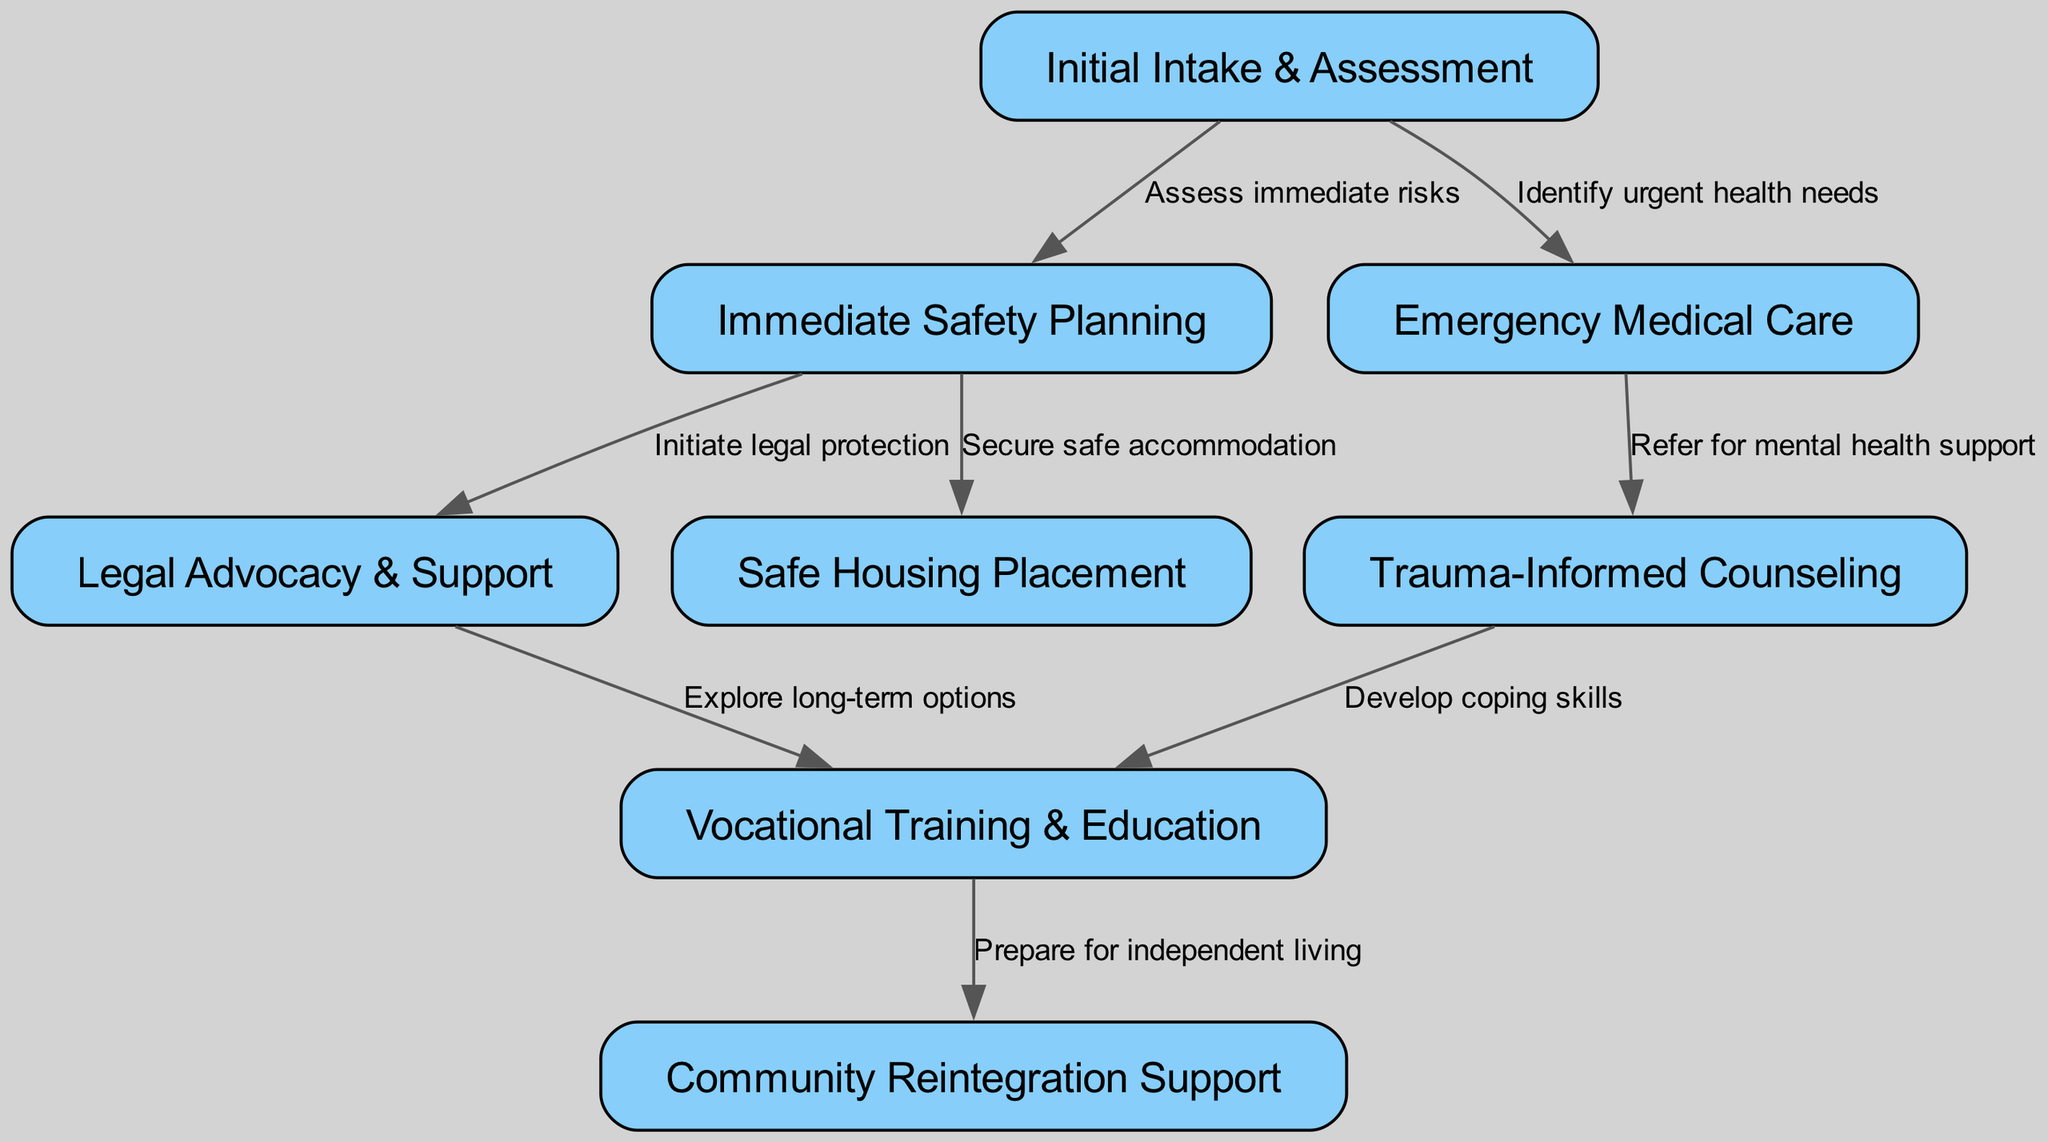What is the first step in the pathway? The diagram indicates that the first step is "Initial Intake & Assessment," which is the starting point of the clinical pathway for support services.
Answer: Initial Intake & Assessment How many nodes are present in the diagram? The diagram contains 8 nodes, each representing a different stage or aspect of the support process for trafficking survivors.
Answer: 8 What service follows “Emergency Medical Care”? After "Emergency Medical Care," the next step indicated in the diagram is "Trauma-Informed Counseling," showing a direct connection from medical care to mental health support.
Answer: Trauma-Informed Counseling What do we secure after Immediate Safety Planning? After "Immediate Safety Planning," we secure "Safe Housing Placement," which is represented as the next step that provides accommodation to enhance safety.
Answer: Safe Housing Placement What is the relationship between "Legal Advocacy & Support" and "Vocational Training & Education"? "Legal Advocacy & Support" is connected to "Vocational Training & Education" through the label "Explore long-term options," indicating a supportive flow from legal aspects to rehabilitation.
Answer: Explore long-term options What does the "Trauma-Informed Counseling" lead to? "Trauma-Informed Counseling" leads to "Vocational Training & Education," which emphasizes the development of coping skills as part of the rehabilitation process.
Answer: Vocational Training & Education How many edges are depicted in the diagram? The diagram has 7 edges, which illustrate the connections and flow between the various services mentioned in the pathway.
Answer: 7 What is the last step in the pathway? The last step in the clinical pathway is "Community Reintegration Support," which signifies the final phase where survivors are helped to reintegrate into society.
Answer: Community Reintegration Support What does the "Emergency Medical Care" lead to? "Emergency Medical Care" leads to "Trauma-Informed Counseling," indicating the need for mental health support following medical attention.
Answer: Trauma-Informed Counseling 